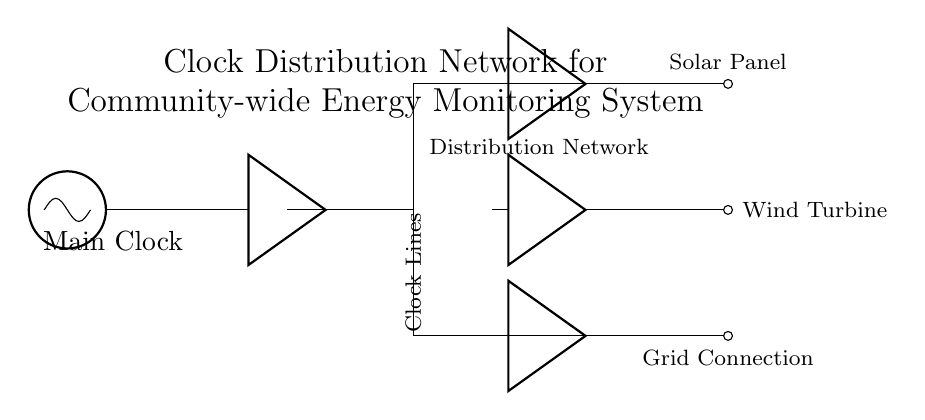What is the main component of the circuit? The main component is the oscillator labeled as "Main Clock," which serves as the source of the clock signals for the distribution network.
Answer: Main Clock How many monitoring points are present in the circuit? There are three monitoring points labeled as Solar Panel, Wind Turbine, and Grid Connection, indicating the sources being monitored in the community energy system.
Answer: Three What connects the clock buffer to the distribution network? The clock buffer is connected to the distribution network through a direct line indicating that the clock signals are distributed from the buffer to other components in the network.
Answer: A direct line What do the local buffers represent in this circuit? The local buffers serve to strengthen or improve the quality of the clock signals before they reach each monitoring point, ensuring that the signals maintain integrity over distance.
Answer: They strengthen clock signals How are the monitoring points organized in relation to the distribution network? The monitoring points are organized in a way that they branch off from the main distribution line at specific intervals, indicating a structured approach to energy monitoring within the community.
Answer: Branch off from the main line What is the purpose of the distribution network in this circuit? The distribution network's purpose is to route clock signals from the main clock to the local buffers and subsequently to the monitoring points, ensuring all components are synchronized for effective energy monitoring.
Answer: Route clock signals 